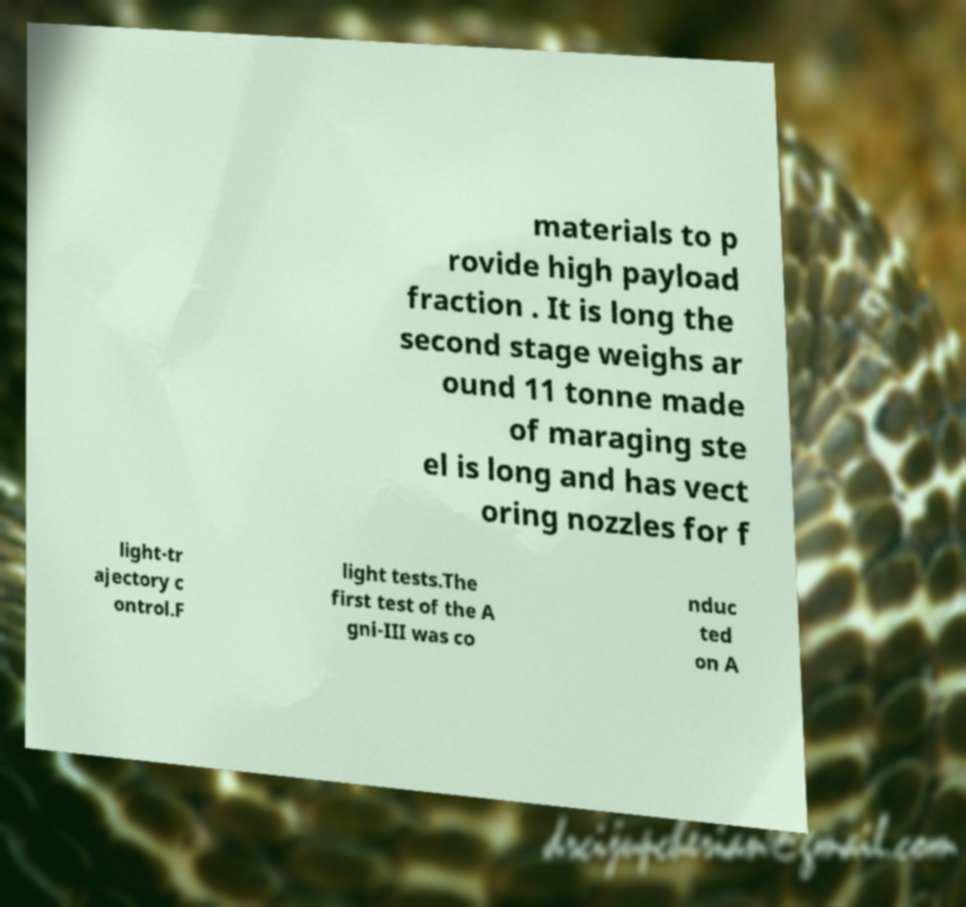What messages or text are displayed in this image? I need them in a readable, typed format. materials to p rovide high payload fraction . It is long the second stage weighs ar ound 11 tonne made of maraging ste el is long and has vect oring nozzles for f light-tr ajectory c ontrol.F light tests.The first test of the A gni-III was co nduc ted on A 